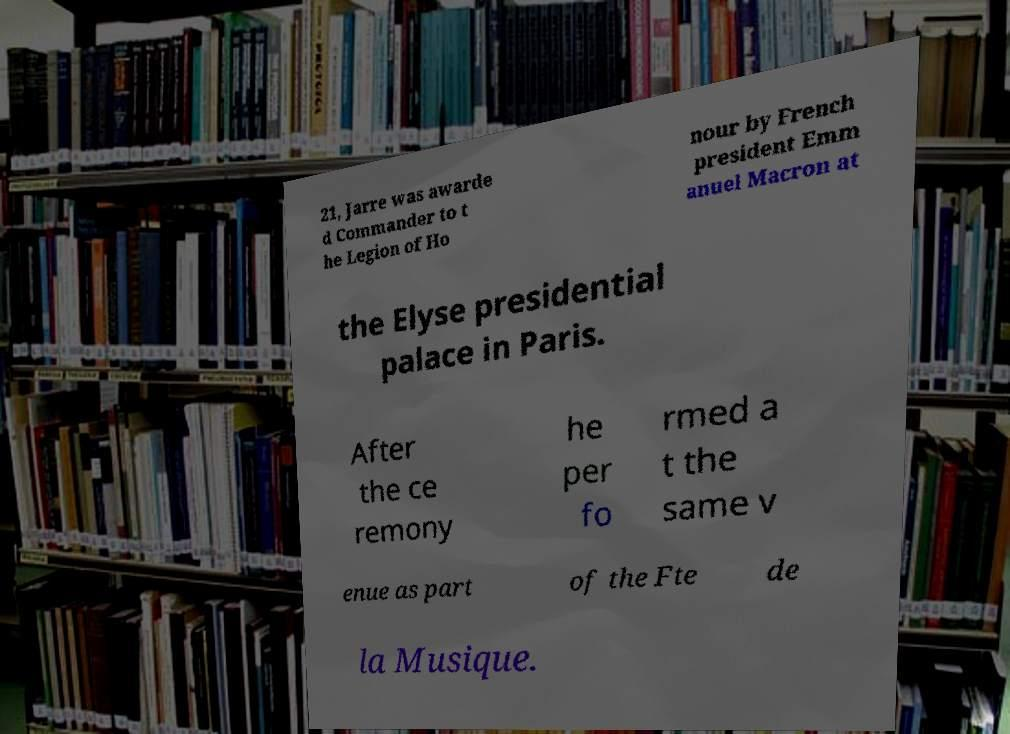Please identify and transcribe the text found in this image. 21, Jarre was awarde d Commander to t he Legion of Ho nour by French president Emm anuel Macron at the Elyse presidential palace in Paris. After the ce remony he per fo rmed a t the same v enue as part of the Fte de la Musique. 